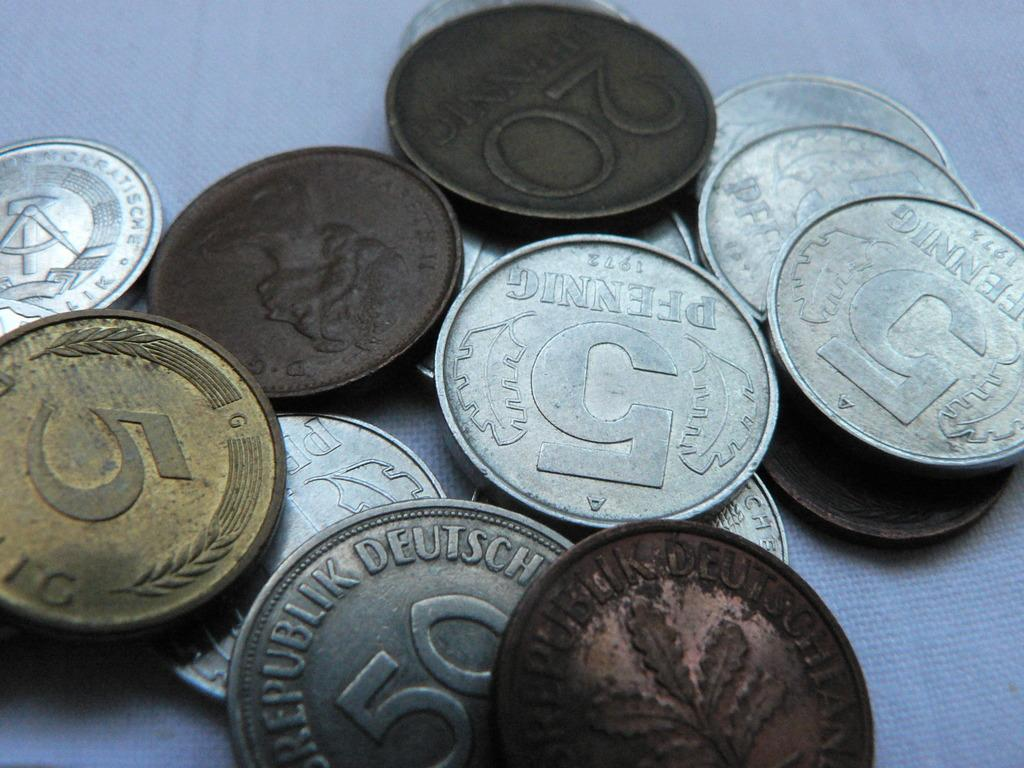<image>
Describe the image concisely. The coin collection was worthless in the United States. 